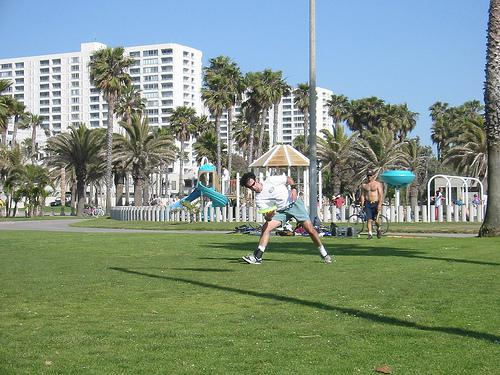Question: what game are they playing?
Choices:
A. Soccer.
B. Football.
C. Basketball.
D. Frisbee.
Answer with the letter. Answer: D Question: where is the frisbee?
Choices:
A. Dog's  mouth.
B. In the air.
C. Boy's hands.
D. On ground.
Answer with the letter. Answer: B Question: how many men?
Choices:
A. One.
B. Three.
C. Two.
D. Five.
Answer with the letter. Answer: C Question: what is green?
Choices:
A. Leaves.
B. Grass.
C. Lake water.
D. Weeds.
Answer with the letter. Answer: B Question: who is catching?
Choices:
A. The little boy.
B. The baseball player.
C. Man.
D. Catcher.
Answer with the letter. Answer: C 